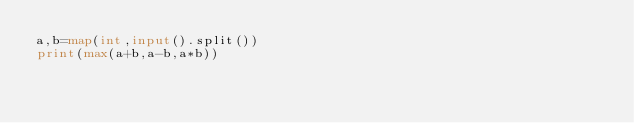Convert code to text. <code><loc_0><loc_0><loc_500><loc_500><_Python_>a,b=map(int,input().split())
print(max(a+b,a-b,a*b))                </code> 